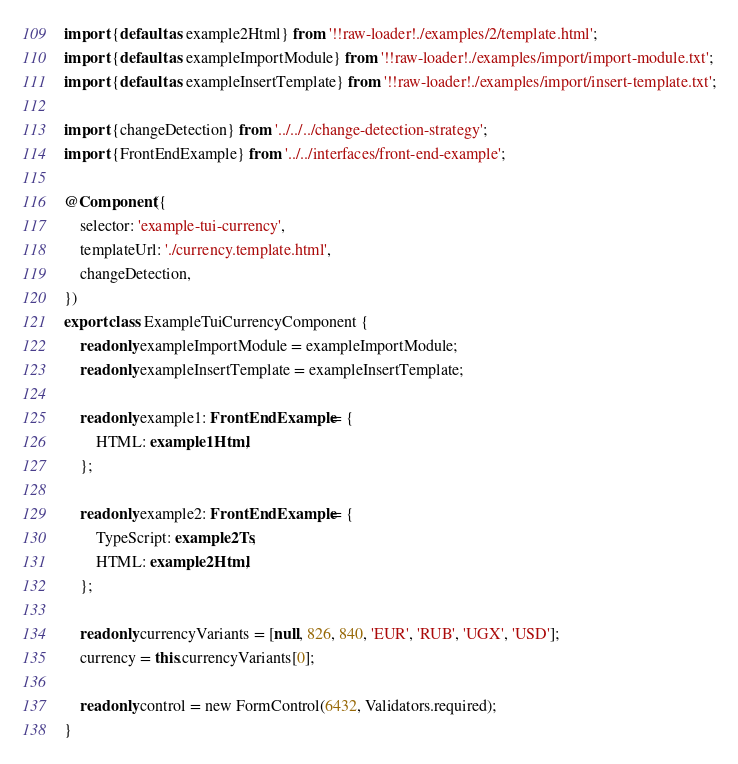<code> <loc_0><loc_0><loc_500><loc_500><_TypeScript_>import {default as example2Html} from '!!raw-loader!./examples/2/template.html';
import {default as exampleImportModule} from '!!raw-loader!./examples/import/import-module.txt';
import {default as exampleInsertTemplate} from '!!raw-loader!./examples/import/insert-template.txt';

import {changeDetection} from '../../../change-detection-strategy';
import {FrontEndExample} from '../../interfaces/front-end-example';

@Component({
    selector: 'example-tui-currency',
    templateUrl: './currency.template.html',
    changeDetection,
})
export class ExampleTuiCurrencyComponent {
    readonly exampleImportModule = exampleImportModule;
    readonly exampleInsertTemplate = exampleInsertTemplate;

    readonly example1: FrontEndExample = {
        HTML: example1Html,
    };

    readonly example2: FrontEndExample = {
        TypeScript: example2Ts,
        HTML: example2Html,
    };

    readonly currencyVariants = [null, 826, 840, 'EUR', 'RUB', 'UGX', 'USD'];
    currency = this.currencyVariants[0];

    readonly control = new FormControl(6432, Validators.required);
}
</code> 